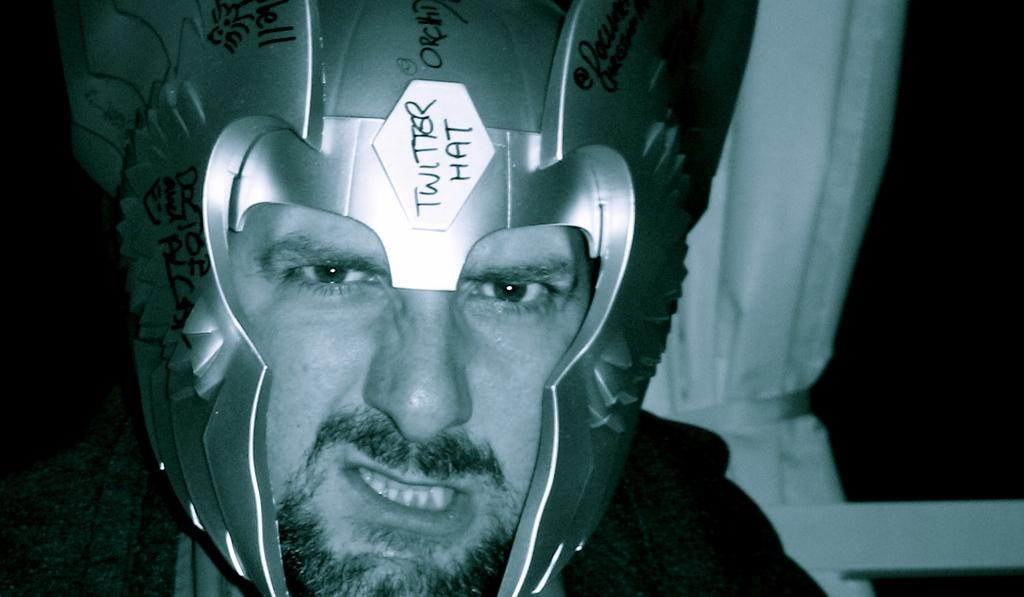Who is present in the image? There is a man in the image. What is the man wearing on his head? The man is wearing a crown. What can be seen on the crown? There is text written on the crown. What color is the object in the background of the image? There is a white color object in the background of the image. How does the man sail in the image? The image does not depict the man sailing; he is wearing a crown and there is no indication of sailing. 